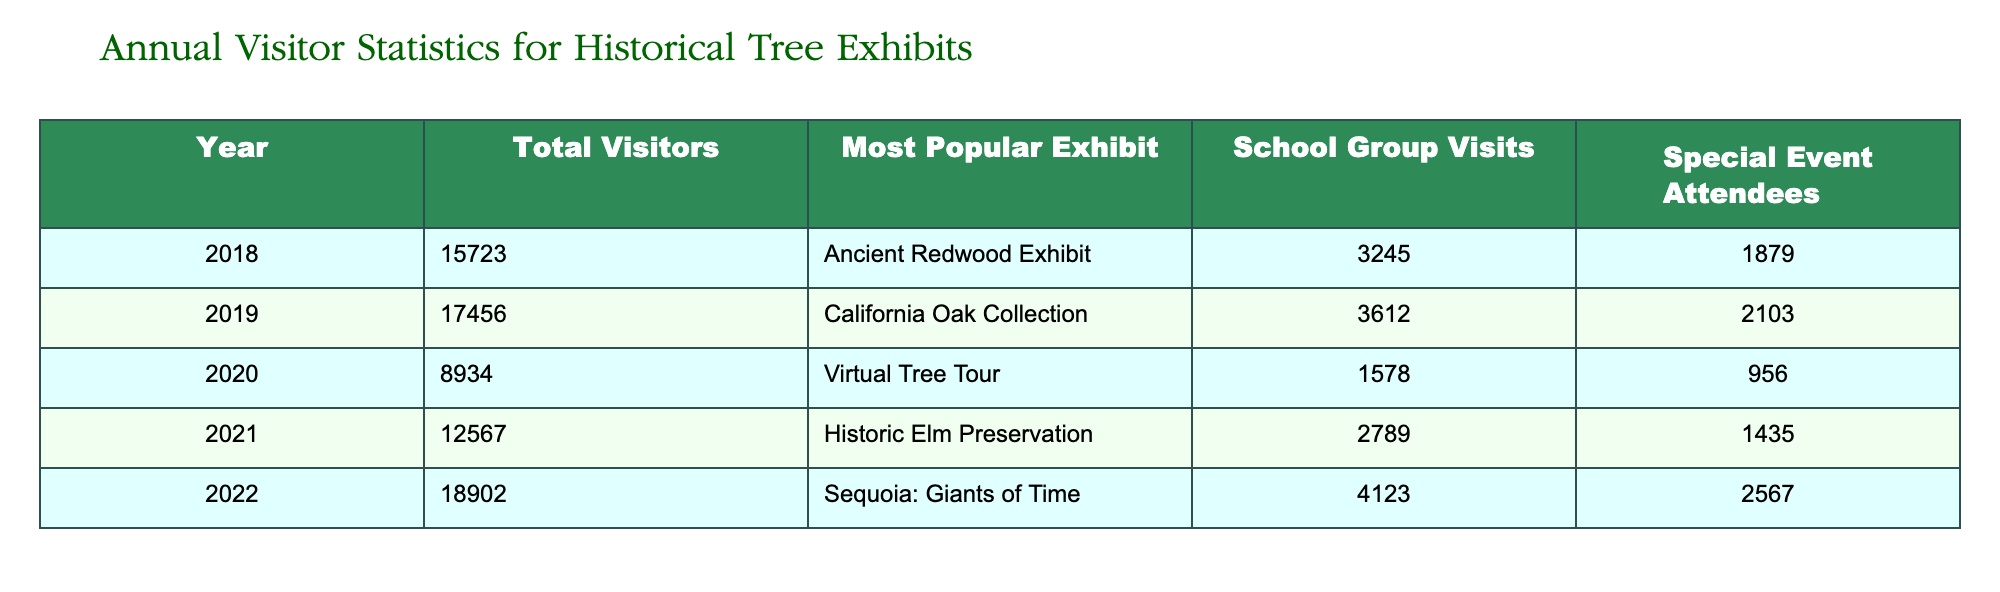What year had the highest total visitors? By examining the 'Total Visitors' column, we see the values are: 15723 (2018), 17456 (2019), 8934 (2020), 12567 (2021), and 18902 (2022). The maximum value is 18902 in the year 2022.
Answer: 2022 What was the most popular exhibit in 2020? Looking at the 'Most Popular Exhibit' column for the year 2020, we find that the exhibit is "Virtual Tree Tour."
Answer: Virtual Tree Tour How many school group visits were there in total from 2018 to 2021? To find the total school group visits, we sum the values for each year: 3245 (2018) + 3612 (2019) + 1578 (2020) + 2789 (2021) = 11224.
Answer: 11224 Did the number of special event attendees increase from 2018 to 2022? We compare the values of special event attendees: 1879 (2018), 2103 (2019), 956 (2020), 1435 (2021), and 2567 (2022). It clearly rises from 956 in 2020 to 2567 in 2022, confirming an increase overall after 2020.
Answer: Yes What is the average number of total visitors over the five years? To calculate the average, we sum the total visitors: 15723 + 17456 + 8934 + 12567 + 18902 = 72582. Dividing by 5 gives an average of 14516.4, which can be rounded to 14516.
Answer: 14516 